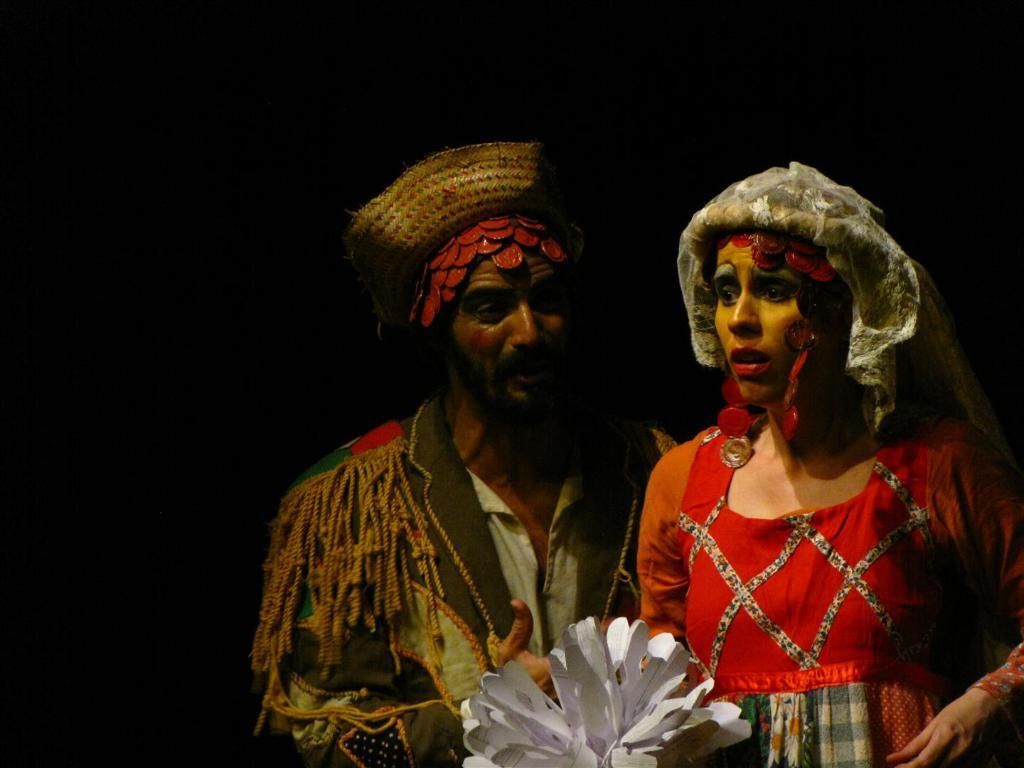Who or what can be seen in the image? There are people in the image. What are the people doing in the image? The people are standing. What are the people wearing in the image? The people are wearing costumes. What are the people holding in their hands in the image? The people are holding paper flowers in their hands. What type of sock is the achiever wearing in the image? There is no achiever or sock mentioned in the image. The image only features people wearing costumes and holding paper flowers. 